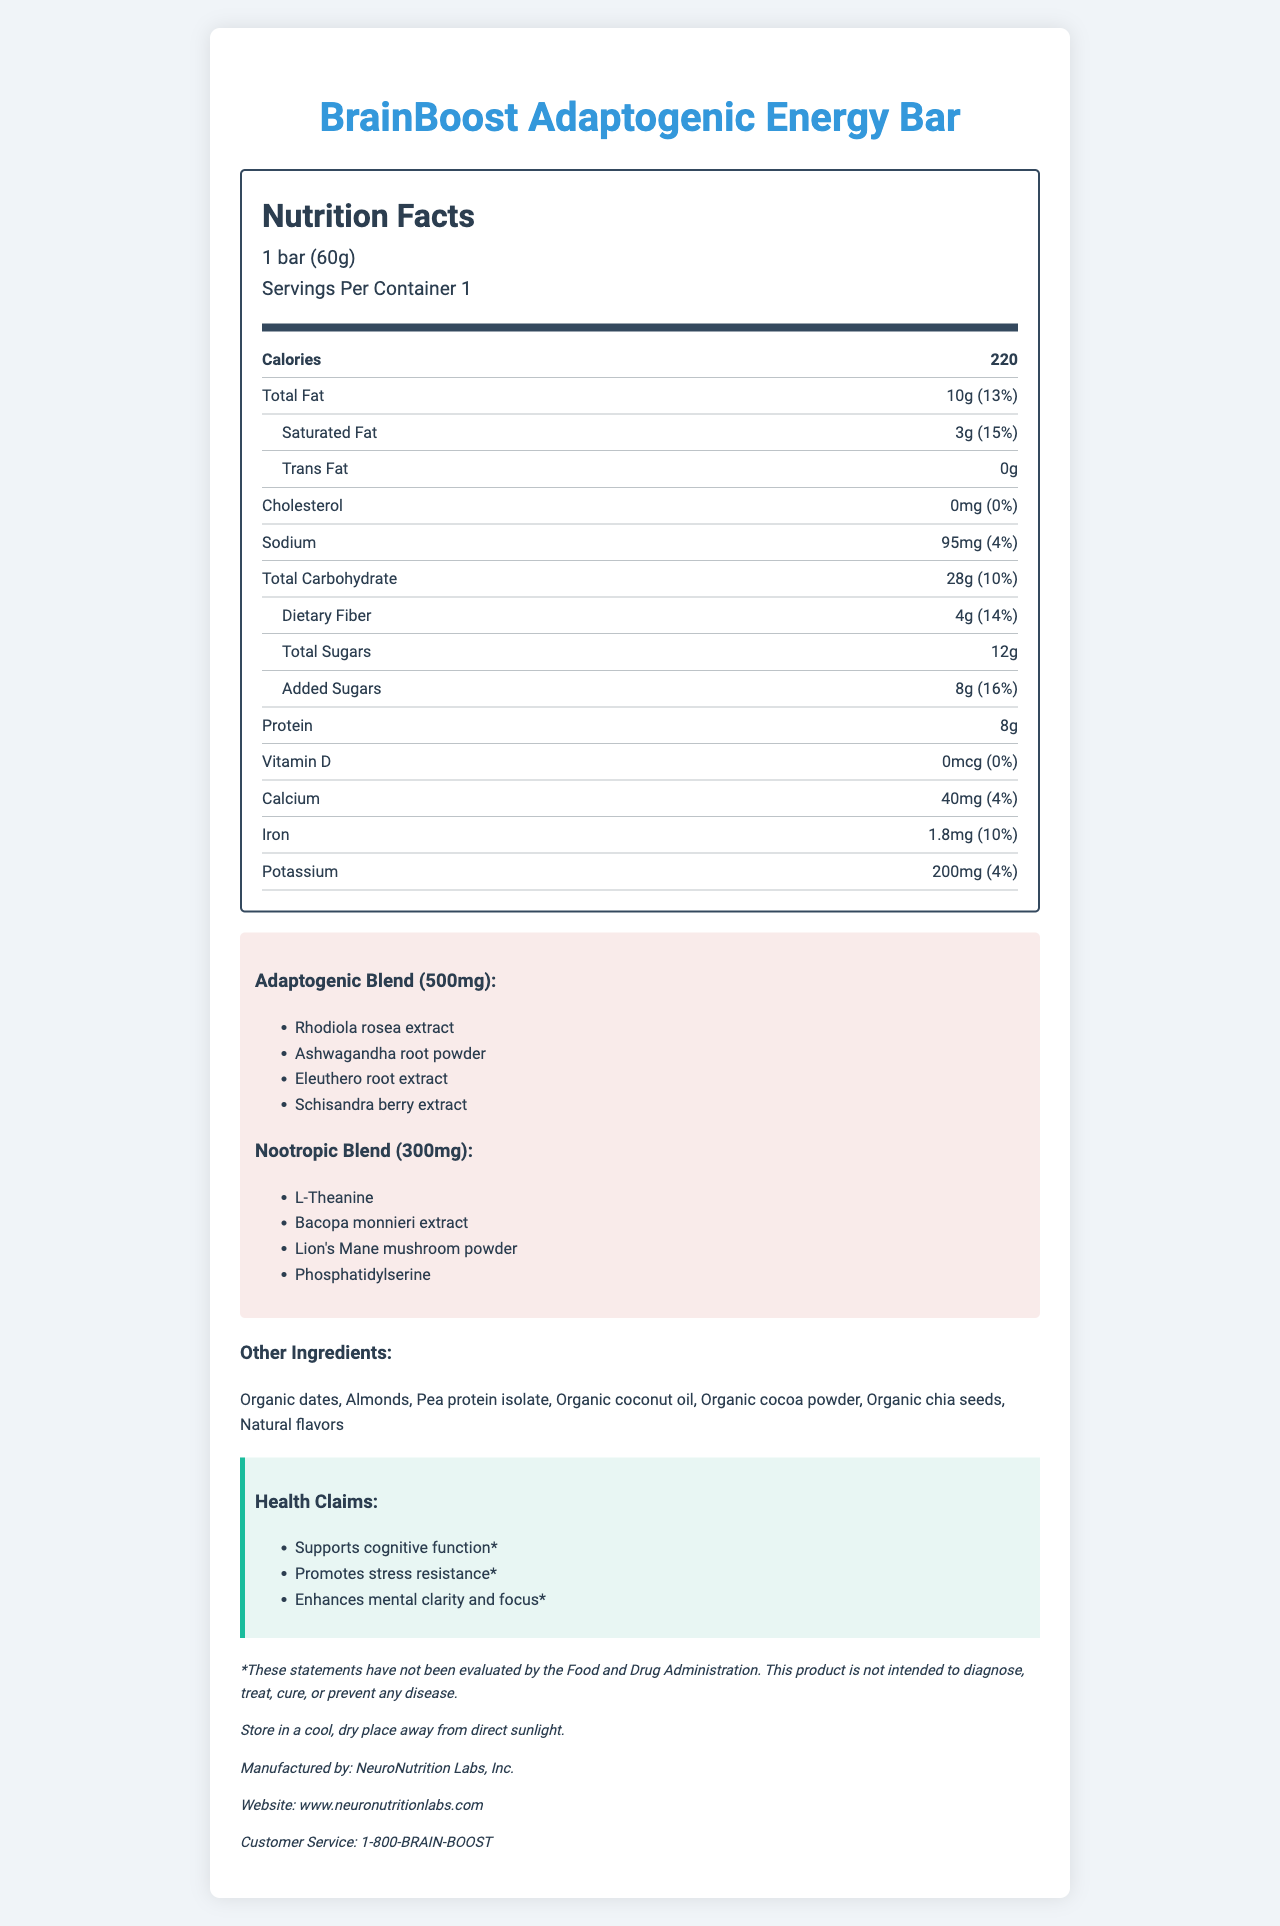what is the total fat content per serving? The document states that the total fat content per serving is 10g.
Answer: 10g what percentage of the daily value of saturated fat does one serving of the energy bar provide? The document specifies that one serving of the energy bar provides 3g of saturated fat, which is 15% of the daily value.
Answer: 15% how much dietary fiber is in each serving? The document notes that each serving contains 4g of dietary fiber.
Answer: 4g what are the main ingredients in the nootropic blend? The document lists the ingredients of the nootropic blend as L-Theanine, Bacopa monnieri extract, Lion's Mane mushroom powder, and Phosphatidylserine.
Answer: L-Theanine, Bacopa monnieri extract, Lion's Mane mushroom powder, Phosphatidylserine what is the caloric content of one serving of the BrainBoost Adaptogenic Energy Bar? The document states that one serving (1 bar) contains 220 calories.
Answer: 220 calories how much sodium is in each serving of the energy bar? The document specifies that each serving contains 95mg of sodium.
Answer: 95mg does the energy bar contain any cholesterol? The document indicates that the energy bar contains 0mg of cholesterol, which is 0% of the daily value.
Answer: No which of the following is NOT an ingredient in the adaptogenic blend? A. Rhodiola rosea extract B. Ashwagandha root powder C. L-Theanine D. Schisandra berry extract The document lists the ingredients of the adaptogenic blend as Rhodiola rosea extract, Ashwagandha root powder, Eleuthero root extract, and Schisandra berry extract. L-Theanine is part of the nootropic blend.
Answer: C which ingredient is mentioned in both the nootropic and adaptogenic blends? 1. Bacopa monnieri 2. Ashwagandha 3. Lion's Mane mushroom 4. None The document specifies separate ingredients for the nootropic and adaptogenic blends without any overlaps.
Answer: 4 does the energy bar contain any artificial flavors? The document lists natural flavors as one of the ingredients, without any mention of artificial flavors.
Answer: No summarize the main health claims made by the BrainBoost Adaptogenic Energy Bar. The document states that the energy bar supports cognitive function, promotes stress resistance, and enhances mental clarity and focus, though it notes that these claims have not been evaluated by the FDA.
Answer: Supports cognitive function, promotes stress resistance, and enhances mental clarity and focus who manufactures the BrainBoost Adaptogenic Energy Bar? The document specifies that the energy bar is manufactured by NeuroNutrition Labs, Inc.
Answer: NeuroNutrition Labs, Inc. what is the protein content of the energy bar per serving? The document states that one serving of the energy bar contains 8g of protein.
Answer: 8g why might someone with nut allergies avoid this energy bar? The document notes that the energy bar contains tree nuts (almonds) and is manufactured in a facility that also processes peanuts, soy, and milk products, which could be problematic for someone with nut allergies.
Answer: Contains almonds and is manufactured in a facility that processes peanuts, soy, and milk products what is the recommended storage condition for the energy bar? The document provides storage instructions, recommending that the energy bar be stored in a cool, dry place away from direct sunlight.
Answer: Store in a cool, dry place away from direct sunlight is the amount of iron provided by the energy bar significant? The document states that each serving provides 1.8mg of iron, which is 10% of the daily value, making it a significant source.
Answer: Yes how much added sugar is in each serving of the energy bar? The document specifies that each serving contains 8g of added sugars.
Answer: 8g is there any information about the environmental sustainability of the product? The document does not provide details about the environmental sustainability of the product.
Answer: Not enough information 